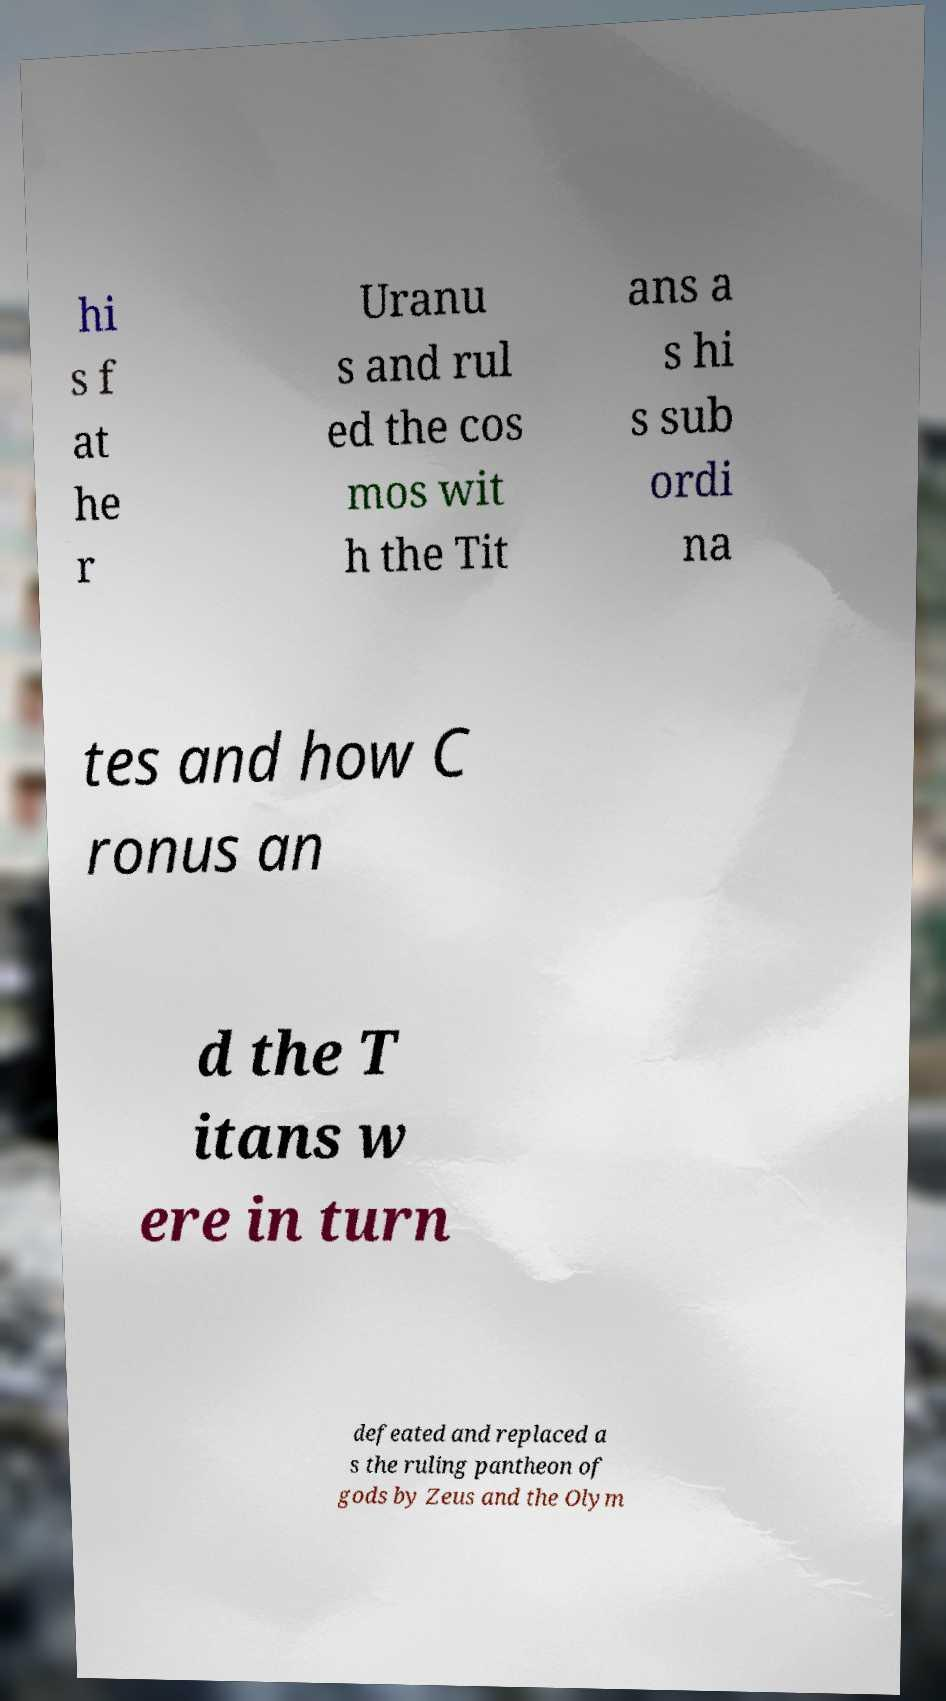Please identify and transcribe the text found in this image. hi s f at he r Uranu s and rul ed the cos mos wit h the Tit ans a s hi s sub ordi na tes and how C ronus an d the T itans w ere in turn defeated and replaced a s the ruling pantheon of gods by Zeus and the Olym 